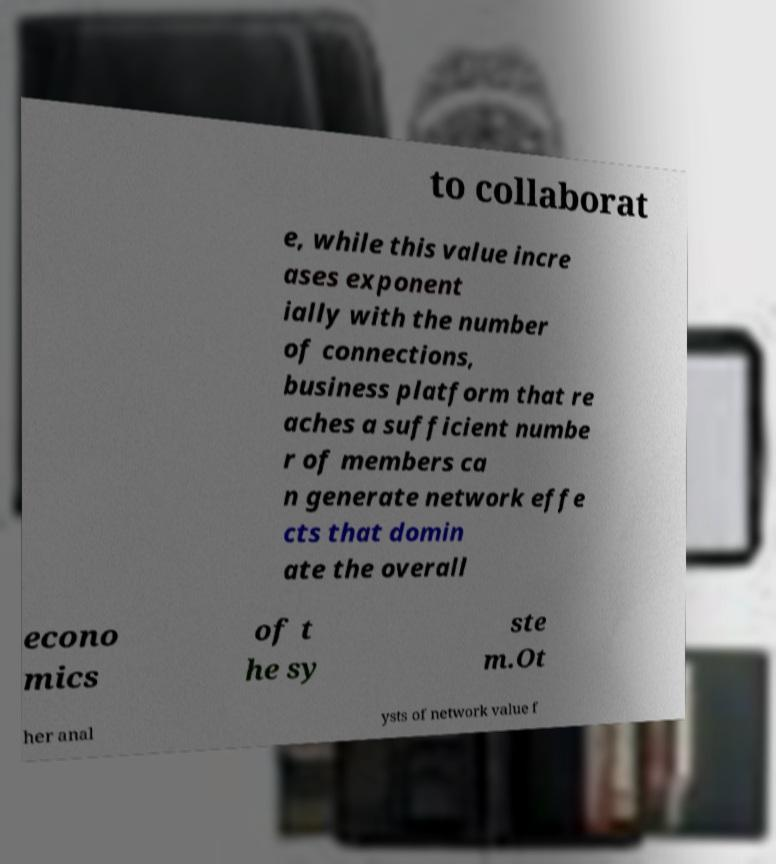I need the written content from this picture converted into text. Can you do that? to collaborat e, while this value incre ases exponent ially with the number of connections, business platform that re aches a sufficient numbe r of members ca n generate network effe cts that domin ate the overall econo mics of t he sy ste m.Ot her anal ysts of network value f 